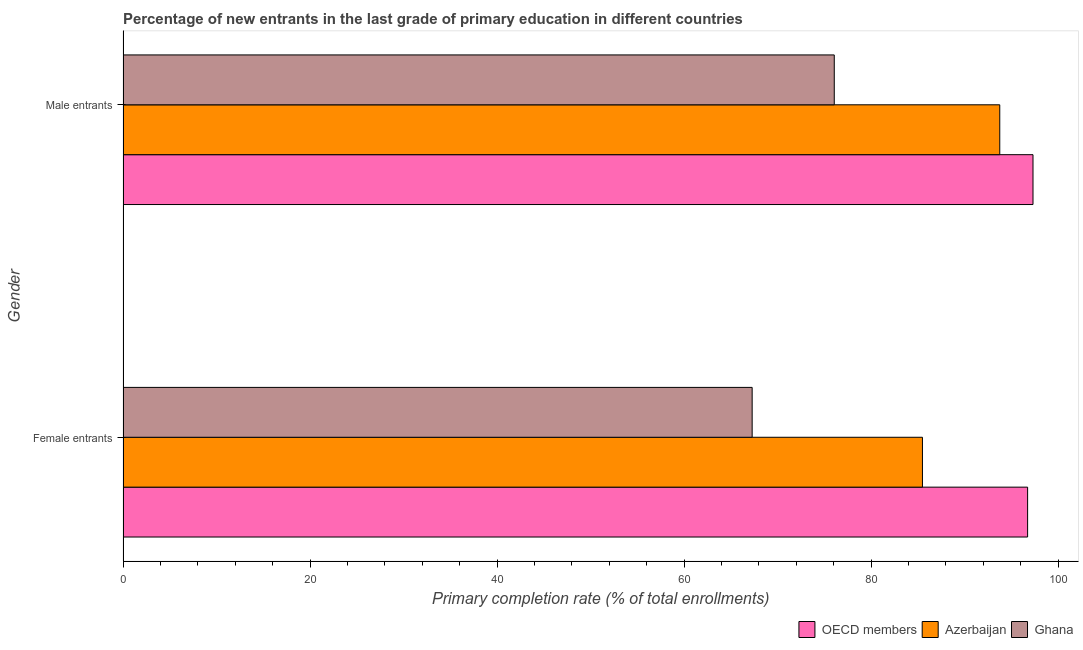How many groups of bars are there?
Your answer should be very brief. 2. Are the number of bars per tick equal to the number of legend labels?
Make the answer very short. Yes. How many bars are there on the 2nd tick from the bottom?
Offer a terse response. 3. What is the label of the 1st group of bars from the top?
Your response must be concise. Male entrants. What is the primary completion rate of male entrants in OECD members?
Offer a very short reply. 97.32. Across all countries, what is the maximum primary completion rate of female entrants?
Keep it short and to the point. 96.74. Across all countries, what is the minimum primary completion rate of male entrants?
Offer a terse response. 76.07. In which country was the primary completion rate of male entrants maximum?
Keep it short and to the point. OECD members. What is the total primary completion rate of female entrants in the graph?
Your response must be concise. 249.53. What is the difference between the primary completion rate of male entrants in Azerbaijan and that in OECD members?
Keep it short and to the point. -3.55. What is the difference between the primary completion rate of male entrants in Azerbaijan and the primary completion rate of female entrants in Ghana?
Offer a very short reply. 26.48. What is the average primary completion rate of male entrants per country?
Make the answer very short. 89.05. What is the difference between the primary completion rate of female entrants and primary completion rate of male entrants in Azerbaijan?
Keep it short and to the point. -8.27. In how many countries, is the primary completion rate of male entrants greater than 48 %?
Keep it short and to the point. 3. What is the ratio of the primary completion rate of male entrants in OECD members to that in Ghana?
Provide a succinct answer. 1.28. What does the 3rd bar from the top in Female entrants represents?
Your response must be concise. OECD members. What does the 1st bar from the bottom in Female entrants represents?
Your response must be concise. OECD members. How many bars are there?
Keep it short and to the point. 6. Are all the bars in the graph horizontal?
Your response must be concise. Yes. How many countries are there in the graph?
Make the answer very short. 3. What is the difference between two consecutive major ticks on the X-axis?
Provide a short and direct response. 20. How are the legend labels stacked?
Make the answer very short. Horizontal. What is the title of the graph?
Offer a very short reply. Percentage of new entrants in the last grade of primary education in different countries. What is the label or title of the X-axis?
Keep it short and to the point. Primary completion rate (% of total enrollments). What is the label or title of the Y-axis?
Provide a succinct answer. Gender. What is the Primary completion rate (% of total enrollments) in OECD members in Female entrants?
Your answer should be compact. 96.74. What is the Primary completion rate (% of total enrollments) of Azerbaijan in Female entrants?
Your response must be concise. 85.5. What is the Primary completion rate (% of total enrollments) of Ghana in Female entrants?
Your answer should be compact. 67.29. What is the Primary completion rate (% of total enrollments) of OECD members in Male entrants?
Give a very brief answer. 97.32. What is the Primary completion rate (% of total enrollments) in Azerbaijan in Male entrants?
Provide a succinct answer. 93.77. What is the Primary completion rate (% of total enrollments) of Ghana in Male entrants?
Ensure brevity in your answer.  76.07. Across all Gender, what is the maximum Primary completion rate (% of total enrollments) of OECD members?
Offer a very short reply. 97.32. Across all Gender, what is the maximum Primary completion rate (% of total enrollments) of Azerbaijan?
Keep it short and to the point. 93.77. Across all Gender, what is the maximum Primary completion rate (% of total enrollments) of Ghana?
Your response must be concise. 76.07. Across all Gender, what is the minimum Primary completion rate (% of total enrollments) of OECD members?
Provide a short and direct response. 96.74. Across all Gender, what is the minimum Primary completion rate (% of total enrollments) of Azerbaijan?
Make the answer very short. 85.5. Across all Gender, what is the minimum Primary completion rate (% of total enrollments) of Ghana?
Offer a very short reply. 67.29. What is the total Primary completion rate (% of total enrollments) of OECD members in the graph?
Offer a terse response. 194.06. What is the total Primary completion rate (% of total enrollments) of Azerbaijan in the graph?
Ensure brevity in your answer.  179.26. What is the total Primary completion rate (% of total enrollments) in Ghana in the graph?
Keep it short and to the point. 143.35. What is the difference between the Primary completion rate (% of total enrollments) of OECD members in Female entrants and that in Male entrants?
Your answer should be compact. -0.58. What is the difference between the Primary completion rate (% of total enrollments) in Azerbaijan in Female entrants and that in Male entrants?
Offer a very short reply. -8.27. What is the difference between the Primary completion rate (% of total enrollments) in Ghana in Female entrants and that in Male entrants?
Your response must be concise. -8.78. What is the difference between the Primary completion rate (% of total enrollments) in OECD members in Female entrants and the Primary completion rate (% of total enrollments) in Azerbaijan in Male entrants?
Provide a succinct answer. 2.98. What is the difference between the Primary completion rate (% of total enrollments) of OECD members in Female entrants and the Primary completion rate (% of total enrollments) of Ghana in Male entrants?
Your answer should be compact. 20.68. What is the difference between the Primary completion rate (% of total enrollments) in Azerbaijan in Female entrants and the Primary completion rate (% of total enrollments) in Ghana in Male entrants?
Ensure brevity in your answer.  9.43. What is the average Primary completion rate (% of total enrollments) in OECD members per Gender?
Give a very brief answer. 97.03. What is the average Primary completion rate (% of total enrollments) of Azerbaijan per Gender?
Give a very brief answer. 89.63. What is the average Primary completion rate (% of total enrollments) of Ghana per Gender?
Offer a very short reply. 71.68. What is the difference between the Primary completion rate (% of total enrollments) in OECD members and Primary completion rate (% of total enrollments) in Azerbaijan in Female entrants?
Offer a terse response. 11.25. What is the difference between the Primary completion rate (% of total enrollments) of OECD members and Primary completion rate (% of total enrollments) of Ghana in Female entrants?
Provide a succinct answer. 29.46. What is the difference between the Primary completion rate (% of total enrollments) in Azerbaijan and Primary completion rate (% of total enrollments) in Ghana in Female entrants?
Offer a very short reply. 18.21. What is the difference between the Primary completion rate (% of total enrollments) of OECD members and Primary completion rate (% of total enrollments) of Azerbaijan in Male entrants?
Your answer should be compact. 3.55. What is the difference between the Primary completion rate (% of total enrollments) of OECD members and Primary completion rate (% of total enrollments) of Ghana in Male entrants?
Give a very brief answer. 21.25. What is the difference between the Primary completion rate (% of total enrollments) of Azerbaijan and Primary completion rate (% of total enrollments) of Ghana in Male entrants?
Provide a short and direct response. 17.7. What is the ratio of the Primary completion rate (% of total enrollments) in OECD members in Female entrants to that in Male entrants?
Offer a very short reply. 0.99. What is the ratio of the Primary completion rate (% of total enrollments) in Azerbaijan in Female entrants to that in Male entrants?
Offer a terse response. 0.91. What is the ratio of the Primary completion rate (% of total enrollments) in Ghana in Female entrants to that in Male entrants?
Your answer should be very brief. 0.88. What is the difference between the highest and the second highest Primary completion rate (% of total enrollments) of OECD members?
Keep it short and to the point. 0.58. What is the difference between the highest and the second highest Primary completion rate (% of total enrollments) of Azerbaijan?
Offer a very short reply. 8.27. What is the difference between the highest and the second highest Primary completion rate (% of total enrollments) of Ghana?
Your response must be concise. 8.78. What is the difference between the highest and the lowest Primary completion rate (% of total enrollments) of OECD members?
Provide a succinct answer. 0.58. What is the difference between the highest and the lowest Primary completion rate (% of total enrollments) in Azerbaijan?
Your answer should be very brief. 8.27. What is the difference between the highest and the lowest Primary completion rate (% of total enrollments) of Ghana?
Offer a terse response. 8.78. 